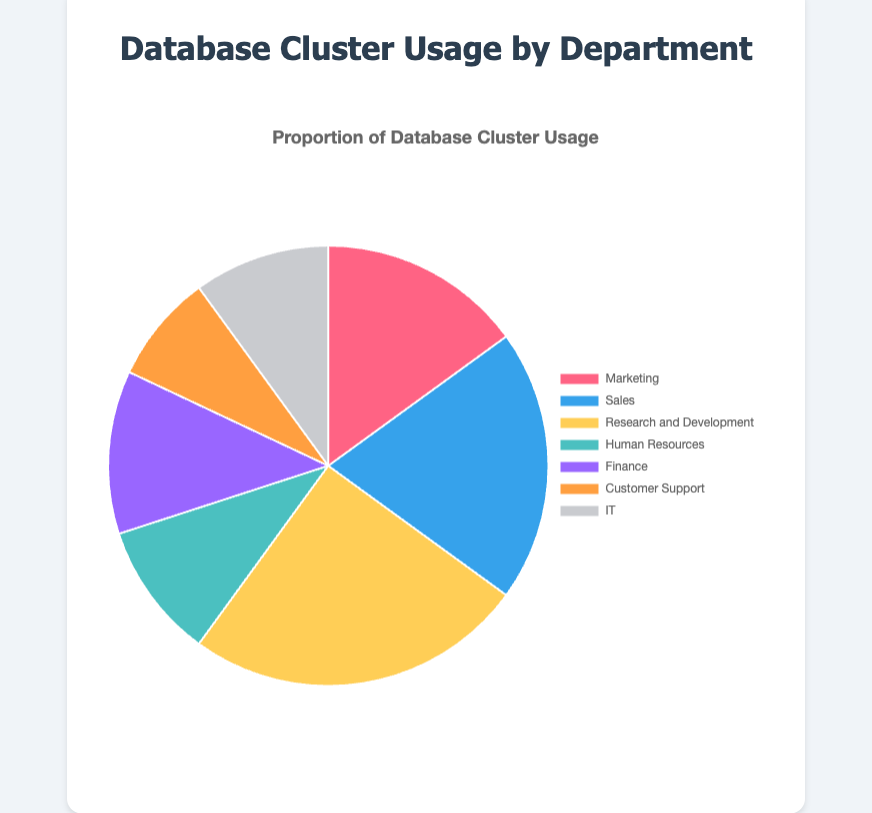What percentage of the database cluster is used by the Sales department? The Sales department usage proportion is clearly indicated as 20% on the pie chart.
Answer: 20% What is the combined usage percentage of the Finance and IT departments? Finance has a 12% usage proportion and IT has a 10% usage proportion. Adding these together gives 12% + 10% = 22%.
Answer: 22% Which department has the lowest usage proportion and what is that proportion? From the pie chart, Customer Support has the lowest usage proportion at 8%.
Answer: Customer Support, 8% Compare the usage proportions of Marketing and Human Resources. Which department uses more and by what percentage? Marketing has a usage proportion of 15% while Human Resources has 10%. The difference is 15% - 10% = 5%. Thus, Marketing uses 5% more.
Answer: Marketing, 5% What is the total usage percentage of departments that each use 10% or less? The departments with 10% or less are Human Resources (10%), IT (10%), and Customer Support (8%). Adding these gives 10% + 10% + 8% = 28%.
Answer: 28% Which department uses the most database cluster space and what is the proportion? The Research and Development department uses the most database cluster space at 25%.
Answer: Research and Development, 25% Identify the percentage difference between the department with the highest usage and the department with the second-highest usage. The highest is Research and Development at 25%, and the second-highest is Sales at 20%. The difference is 25% - 20% = 5%.
Answer: 5% Which department uses exactly half the database space compared to the Research and Development department? Research and Development uses 25%, so half of that is 12.5%. No department uses exactly 12.5%, but Finance with 12% is the closest.
Answer: None exactly, closest is Finance What is the average usage proportion across all the departments? Sum of all proportions: 15% (Marketing) + 20% (Sales) + 25% (Research and Development) + 10% (Human Resources) + 12% (Finance) + 8% (Customer Support) + 10% (IT) = 100%. The average is 100% / 7 = 14.29%.
Answer: 14.29% What portion of the total database usage does the combination of Marketing, Sales, and Finance departments represent? Sum of usages: Marketing (15%) + Sales (20%) + Finance (12%) = 15% + 20% + 12% = 47%.
Answer: 47% 